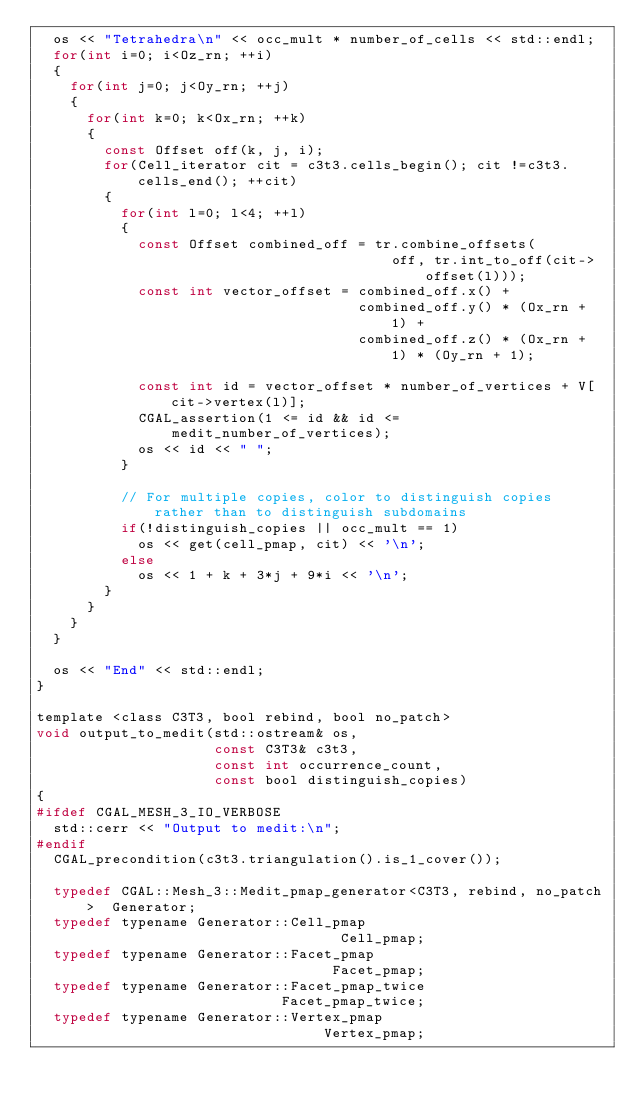<code> <loc_0><loc_0><loc_500><loc_500><_C_>  os << "Tetrahedra\n" << occ_mult * number_of_cells << std::endl;
  for(int i=0; i<Oz_rn; ++i)
  {
    for(int j=0; j<Oy_rn; ++j)
    {
      for(int k=0; k<Ox_rn; ++k)
      {
        const Offset off(k, j, i);
        for(Cell_iterator cit = c3t3.cells_begin(); cit !=c3t3.cells_end(); ++cit)
        {
          for(int l=0; l<4; ++l)
          {
            const Offset combined_off = tr.combine_offsets(
                                          off, tr.int_to_off(cit->offset(l)));
            const int vector_offset = combined_off.x() +
                                      combined_off.y() * (Ox_rn + 1) +
                                      combined_off.z() * (Ox_rn + 1) * (Oy_rn + 1);

            const int id = vector_offset * number_of_vertices + V[cit->vertex(l)];
            CGAL_assertion(1 <= id && id <= medit_number_of_vertices);
            os << id << " ";
          }

          // For multiple copies, color to distinguish copies rather than to distinguish subdomains
          if(!distinguish_copies || occ_mult == 1)
            os << get(cell_pmap, cit) << '\n';
          else
            os << 1 + k + 3*j + 9*i << '\n';
        }
      }
    }
  }

  os << "End" << std::endl;
}

template <class C3T3, bool rebind, bool no_patch>
void output_to_medit(std::ostream& os,
                     const C3T3& c3t3,
                     const int occurrence_count,
                     const bool distinguish_copies)
{
#ifdef CGAL_MESH_3_IO_VERBOSE
  std::cerr << "Output to medit:\n";
#endif
  CGAL_precondition(c3t3.triangulation().is_1_cover());

  typedef CGAL::Mesh_3::Medit_pmap_generator<C3T3, rebind, no_patch>  Generator;
  typedef typename Generator::Cell_pmap                               Cell_pmap;
  typedef typename Generator::Facet_pmap                              Facet_pmap;
  typedef typename Generator::Facet_pmap_twice                        Facet_pmap_twice;
  typedef typename Generator::Vertex_pmap                             Vertex_pmap;
</code> 